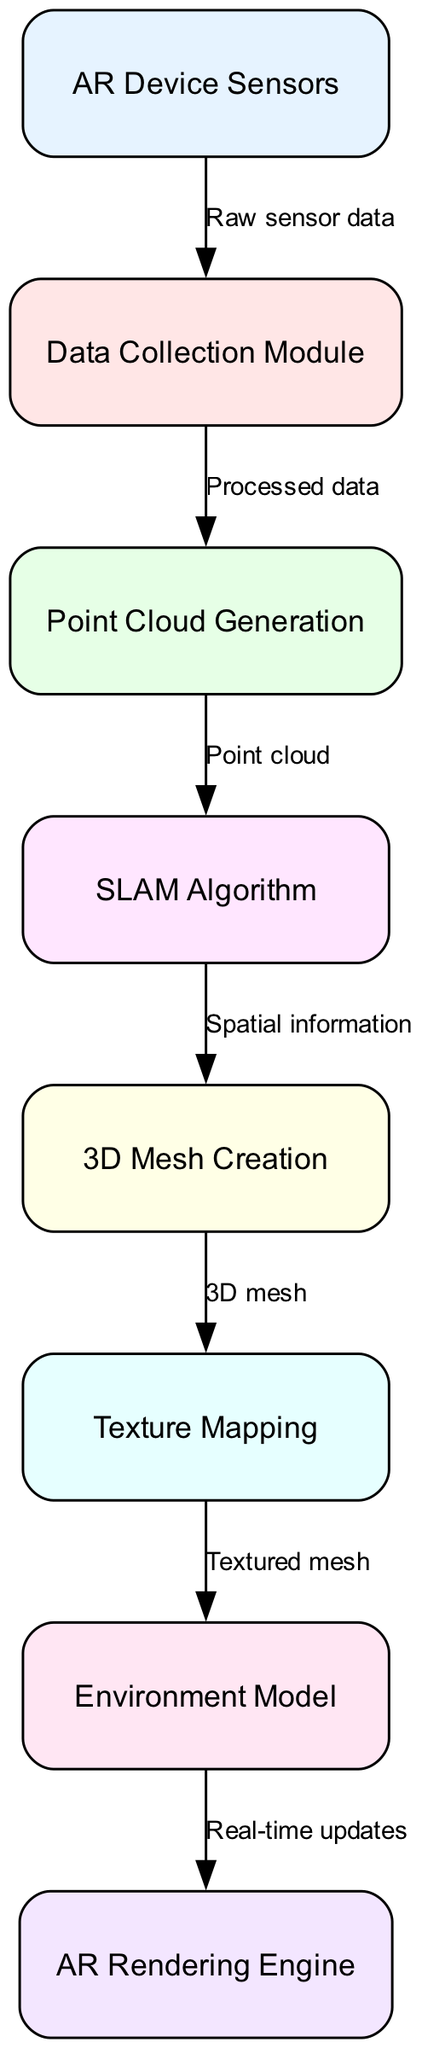What's the first node in the flowchart? The flowchart starts with the "AR Device Sensors" node, which is the first step in the data flow. This is directly indicated in the diagram.
Answer: AR Device Sensors How many nodes are there in total? Counting all the nodes listed in the diagram, there are eight nodes representing different stages of the process from data collection to rendering.
Answer: 8 What is the output of the "3D Mesh Creation" node? The "3D Mesh Creation" node outputs "3D mesh" as indicated by the edge connecting to the node showing what it produces.
Answer: 3D mesh Which node receives "Processed data"? The "Data Collection Module" node receives "Processed data" from the "AR Device Sensors" node, as specified in the flowchart.
Answer: Data Collection Module What is the last step before rendering the environment model? The last step before rendering the environment model is "Texture Mapping," which is the process applied to the "3D mesh" to produce a "Textured mesh."
Answer: Texture Mapping How does the "SLAM Algorithm" contribute to the mapping process? The "SLAM Algorithm" takes "Point cloud" data and outputs "Spatial information," which is essential for building the 3D environment. This coupling shows how spatial awareness is derived from raw inputs.
Answer: Spatial information What type of data flows out of the "Environment Model" node? The "Environment Model" outputs "Real-time updates," which indicates how this model is used in the rendering process of augmented reality.
Answer: Real-time updates Which node comes after "Point Cloud Generation"? The node that comes after "Point Cloud Generation" is the "SLAM Algorithm," which utilizes the point cloud data generated to enhance mapping in AR applications.
Answer: SLAM Algorithm 